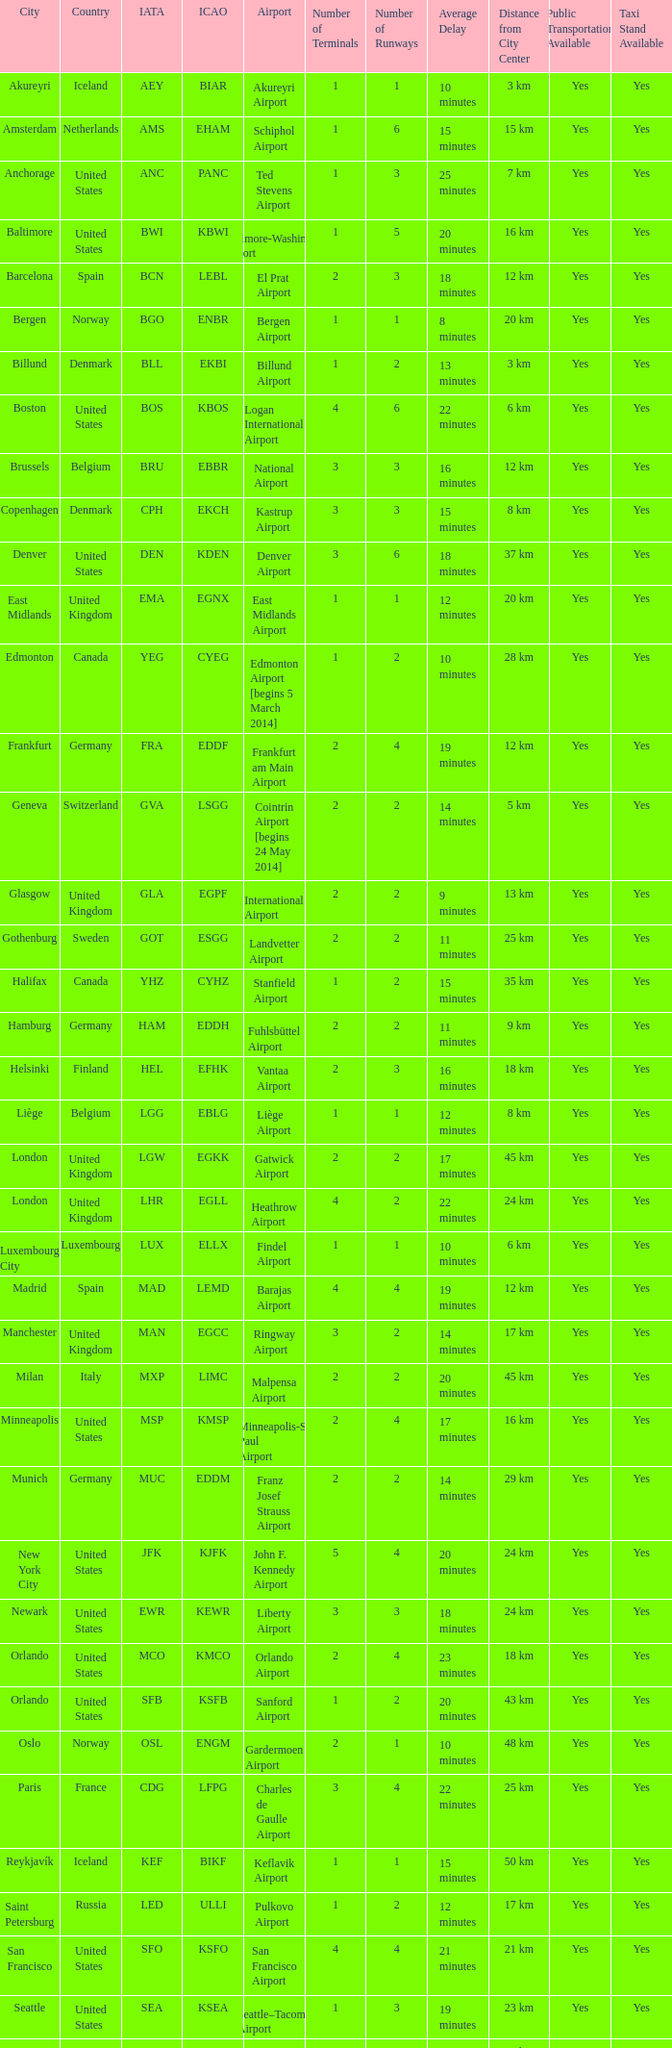What is the IATA OF Akureyri? AEY. 